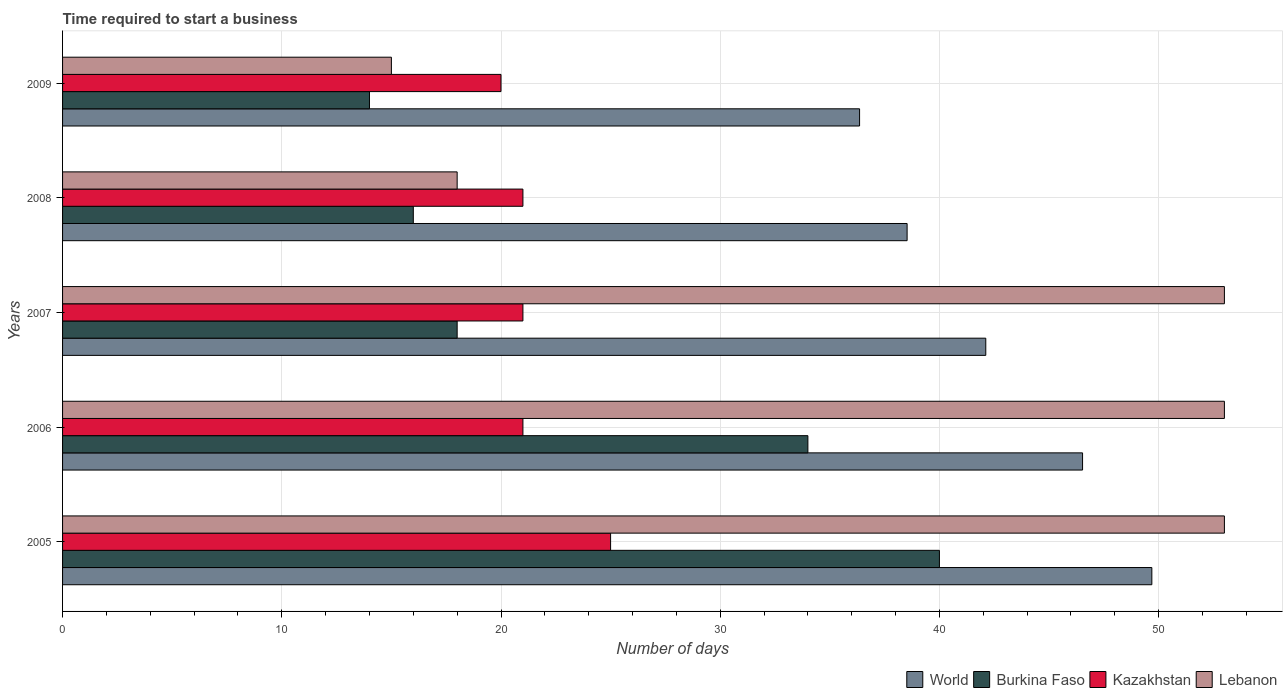How many different coloured bars are there?
Your answer should be very brief. 4. How many groups of bars are there?
Provide a short and direct response. 5. Are the number of bars per tick equal to the number of legend labels?
Offer a very short reply. Yes. How many bars are there on the 1st tick from the bottom?
Provide a short and direct response. 4. In how many cases, is the number of bars for a given year not equal to the number of legend labels?
Keep it short and to the point. 0. What is the number of days required to start a business in World in 2006?
Provide a succinct answer. 46.53. Across all years, what is the maximum number of days required to start a business in Burkina Faso?
Keep it short and to the point. 40. Across all years, what is the minimum number of days required to start a business in Burkina Faso?
Your answer should be compact. 14. What is the total number of days required to start a business in Kazakhstan in the graph?
Make the answer very short. 108. What is the difference between the number of days required to start a business in Burkina Faso in 2005 and that in 2009?
Provide a short and direct response. 26. What is the difference between the number of days required to start a business in Kazakhstan in 2006 and the number of days required to start a business in Burkina Faso in 2008?
Give a very brief answer. 5. What is the average number of days required to start a business in Lebanon per year?
Give a very brief answer. 38.4. In the year 2009, what is the difference between the number of days required to start a business in World and number of days required to start a business in Kazakhstan?
Make the answer very short. 16.36. What is the ratio of the number of days required to start a business in World in 2008 to that in 2009?
Your answer should be very brief. 1.06. Is the difference between the number of days required to start a business in World in 2006 and 2008 greater than the difference between the number of days required to start a business in Kazakhstan in 2006 and 2008?
Your answer should be compact. Yes. What is the difference between the highest and the second highest number of days required to start a business in Burkina Faso?
Provide a short and direct response. 6. What is the difference between the highest and the lowest number of days required to start a business in Lebanon?
Make the answer very short. 38. Is the sum of the number of days required to start a business in Burkina Faso in 2008 and 2009 greater than the maximum number of days required to start a business in World across all years?
Your answer should be compact. No. Is it the case that in every year, the sum of the number of days required to start a business in Burkina Faso and number of days required to start a business in Kazakhstan is greater than the sum of number of days required to start a business in World and number of days required to start a business in Lebanon?
Provide a short and direct response. No. Is it the case that in every year, the sum of the number of days required to start a business in Burkina Faso and number of days required to start a business in Kazakhstan is greater than the number of days required to start a business in World?
Make the answer very short. No. How many bars are there?
Keep it short and to the point. 20. How many years are there in the graph?
Offer a very short reply. 5. What is the difference between two consecutive major ticks on the X-axis?
Offer a terse response. 10. Are the values on the major ticks of X-axis written in scientific E-notation?
Your answer should be very brief. No. Does the graph contain grids?
Offer a very short reply. Yes. Where does the legend appear in the graph?
Your answer should be very brief. Bottom right. What is the title of the graph?
Give a very brief answer. Time required to start a business. Does "Algeria" appear as one of the legend labels in the graph?
Provide a short and direct response. No. What is the label or title of the X-axis?
Your response must be concise. Number of days. What is the label or title of the Y-axis?
Your response must be concise. Years. What is the Number of days in World in 2005?
Ensure brevity in your answer.  49.69. What is the Number of days of Lebanon in 2005?
Offer a very short reply. 53. What is the Number of days in World in 2006?
Give a very brief answer. 46.53. What is the Number of days in Lebanon in 2006?
Offer a terse response. 53. What is the Number of days of World in 2007?
Make the answer very short. 42.11. What is the Number of days in Lebanon in 2007?
Make the answer very short. 53. What is the Number of days of World in 2008?
Ensure brevity in your answer.  38.53. What is the Number of days of Burkina Faso in 2008?
Provide a short and direct response. 16. What is the Number of days of Lebanon in 2008?
Give a very brief answer. 18. What is the Number of days of World in 2009?
Your response must be concise. 36.36. What is the Number of days in Burkina Faso in 2009?
Offer a terse response. 14. What is the Number of days in Kazakhstan in 2009?
Offer a terse response. 20. What is the Number of days of Lebanon in 2009?
Your response must be concise. 15. Across all years, what is the maximum Number of days of World?
Ensure brevity in your answer.  49.69. Across all years, what is the maximum Number of days of Lebanon?
Your response must be concise. 53. Across all years, what is the minimum Number of days in World?
Provide a short and direct response. 36.36. Across all years, what is the minimum Number of days of Burkina Faso?
Your response must be concise. 14. Across all years, what is the minimum Number of days of Lebanon?
Your response must be concise. 15. What is the total Number of days of World in the graph?
Provide a short and direct response. 213.22. What is the total Number of days in Burkina Faso in the graph?
Offer a terse response. 122. What is the total Number of days in Kazakhstan in the graph?
Ensure brevity in your answer.  108. What is the total Number of days of Lebanon in the graph?
Provide a short and direct response. 192. What is the difference between the Number of days in World in 2005 and that in 2006?
Offer a terse response. 3.16. What is the difference between the Number of days of Burkina Faso in 2005 and that in 2006?
Your answer should be compact. 6. What is the difference between the Number of days of Lebanon in 2005 and that in 2006?
Your answer should be very brief. 0. What is the difference between the Number of days of World in 2005 and that in 2007?
Make the answer very short. 7.58. What is the difference between the Number of days of World in 2005 and that in 2008?
Offer a very short reply. 11.16. What is the difference between the Number of days in Burkina Faso in 2005 and that in 2008?
Make the answer very short. 24. What is the difference between the Number of days in Lebanon in 2005 and that in 2008?
Your response must be concise. 35. What is the difference between the Number of days in World in 2005 and that in 2009?
Offer a very short reply. 13.33. What is the difference between the Number of days in Burkina Faso in 2005 and that in 2009?
Make the answer very short. 26. What is the difference between the Number of days of Kazakhstan in 2005 and that in 2009?
Provide a short and direct response. 5. What is the difference between the Number of days in Lebanon in 2005 and that in 2009?
Your answer should be compact. 38. What is the difference between the Number of days of World in 2006 and that in 2007?
Provide a succinct answer. 4.42. What is the difference between the Number of days in Kazakhstan in 2006 and that in 2007?
Your answer should be compact. 0. What is the difference between the Number of days of World in 2006 and that in 2008?
Provide a succinct answer. 8. What is the difference between the Number of days in Burkina Faso in 2006 and that in 2008?
Offer a terse response. 18. What is the difference between the Number of days in World in 2006 and that in 2009?
Your response must be concise. 10.17. What is the difference between the Number of days of Burkina Faso in 2006 and that in 2009?
Provide a succinct answer. 20. What is the difference between the Number of days of Kazakhstan in 2006 and that in 2009?
Your answer should be very brief. 1. What is the difference between the Number of days in World in 2007 and that in 2008?
Provide a succinct answer. 3.59. What is the difference between the Number of days in Kazakhstan in 2007 and that in 2008?
Your response must be concise. 0. What is the difference between the Number of days in Lebanon in 2007 and that in 2008?
Give a very brief answer. 35. What is the difference between the Number of days in World in 2007 and that in 2009?
Make the answer very short. 5.76. What is the difference between the Number of days of Burkina Faso in 2007 and that in 2009?
Offer a terse response. 4. What is the difference between the Number of days in Kazakhstan in 2007 and that in 2009?
Make the answer very short. 1. What is the difference between the Number of days in World in 2008 and that in 2009?
Make the answer very short. 2.17. What is the difference between the Number of days of Burkina Faso in 2008 and that in 2009?
Your response must be concise. 2. What is the difference between the Number of days of Lebanon in 2008 and that in 2009?
Ensure brevity in your answer.  3. What is the difference between the Number of days in World in 2005 and the Number of days in Burkina Faso in 2006?
Your answer should be compact. 15.69. What is the difference between the Number of days in World in 2005 and the Number of days in Kazakhstan in 2006?
Offer a very short reply. 28.69. What is the difference between the Number of days of World in 2005 and the Number of days of Lebanon in 2006?
Offer a very short reply. -3.31. What is the difference between the Number of days of Burkina Faso in 2005 and the Number of days of Lebanon in 2006?
Offer a very short reply. -13. What is the difference between the Number of days in World in 2005 and the Number of days in Burkina Faso in 2007?
Your response must be concise. 31.69. What is the difference between the Number of days of World in 2005 and the Number of days of Kazakhstan in 2007?
Keep it short and to the point. 28.69. What is the difference between the Number of days in World in 2005 and the Number of days in Lebanon in 2007?
Provide a short and direct response. -3.31. What is the difference between the Number of days of Kazakhstan in 2005 and the Number of days of Lebanon in 2007?
Ensure brevity in your answer.  -28. What is the difference between the Number of days in World in 2005 and the Number of days in Burkina Faso in 2008?
Your answer should be compact. 33.69. What is the difference between the Number of days of World in 2005 and the Number of days of Kazakhstan in 2008?
Keep it short and to the point. 28.69. What is the difference between the Number of days in World in 2005 and the Number of days in Lebanon in 2008?
Give a very brief answer. 31.69. What is the difference between the Number of days of Kazakhstan in 2005 and the Number of days of Lebanon in 2008?
Make the answer very short. 7. What is the difference between the Number of days in World in 2005 and the Number of days in Burkina Faso in 2009?
Offer a very short reply. 35.69. What is the difference between the Number of days of World in 2005 and the Number of days of Kazakhstan in 2009?
Offer a terse response. 29.69. What is the difference between the Number of days in World in 2005 and the Number of days in Lebanon in 2009?
Provide a short and direct response. 34.69. What is the difference between the Number of days of Burkina Faso in 2005 and the Number of days of Lebanon in 2009?
Provide a short and direct response. 25. What is the difference between the Number of days in Kazakhstan in 2005 and the Number of days in Lebanon in 2009?
Your response must be concise. 10. What is the difference between the Number of days in World in 2006 and the Number of days in Burkina Faso in 2007?
Provide a succinct answer. 28.53. What is the difference between the Number of days of World in 2006 and the Number of days of Kazakhstan in 2007?
Your response must be concise. 25.53. What is the difference between the Number of days of World in 2006 and the Number of days of Lebanon in 2007?
Ensure brevity in your answer.  -6.47. What is the difference between the Number of days in Burkina Faso in 2006 and the Number of days in Lebanon in 2007?
Keep it short and to the point. -19. What is the difference between the Number of days of Kazakhstan in 2006 and the Number of days of Lebanon in 2007?
Give a very brief answer. -32. What is the difference between the Number of days of World in 2006 and the Number of days of Burkina Faso in 2008?
Make the answer very short. 30.53. What is the difference between the Number of days in World in 2006 and the Number of days in Kazakhstan in 2008?
Your answer should be compact. 25.53. What is the difference between the Number of days in World in 2006 and the Number of days in Lebanon in 2008?
Offer a terse response. 28.53. What is the difference between the Number of days in Burkina Faso in 2006 and the Number of days in Kazakhstan in 2008?
Keep it short and to the point. 13. What is the difference between the Number of days of Kazakhstan in 2006 and the Number of days of Lebanon in 2008?
Make the answer very short. 3. What is the difference between the Number of days of World in 2006 and the Number of days of Burkina Faso in 2009?
Keep it short and to the point. 32.53. What is the difference between the Number of days of World in 2006 and the Number of days of Kazakhstan in 2009?
Your answer should be very brief. 26.53. What is the difference between the Number of days in World in 2006 and the Number of days in Lebanon in 2009?
Ensure brevity in your answer.  31.53. What is the difference between the Number of days of Burkina Faso in 2006 and the Number of days of Lebanon in 2009?
Keep it short and to the point. 19. What is the difference between the Number of days in World in 2007 and the Number of days in Burkina Faso in 2008?
Ensure brevity in your answer.  26.11. What is the difference between the Number of days of World in 2007 and the Number of days of Kazakhstan in 2008?
Provide a succinct answer. 21.11. What is the difference between the Number of days in World in 2007 and the Number of days in Lebanon in 2008?
Provide a short and direct response. 24.11. What is the difference between the Number of days of Burkina Faso in 2007 and the Number of days of Kazakhstan in 2008?
Offer a terse response. -3. What is the difference between the Number of days in Burkina Faso in 2007 and the Number of days in Lebanon in 2008?
Offer a terse response. 0. What is the difference between the Number of days of Kazakhstan in 2007 and the Number of days of Lebanon in 2008?
Give a very brief answer. 3. What is the difference between the Number of days in World in 2007 and the Number of days in Burkina Faso in 2009?
Offer a very short reply. 28.11. What is the difference between the Number of days of World in 2007 and the Number of days of Kazakhstan in 2009?
Your answer should be very brief. 22.11. What is the difference between the Number of days in World in 2007 and the Number of days in Lebanon in 2009?
Provide a short and direct response. 27.11. What is the difference between the Number of days of Burkina Faso in 2007 and the Number of days of Lebanon in 2009?
Your answer should be very brief. 3. What is the difference between the Number of days of World in 2008 and the Number of days of Burkina Faso in 2009?
Your answer should be compact. 24.53. What is the difference between the Number of days of World in 2008 and the Number of days of Kazakhstan in 2009?
Offer a very short reply. 18.53. What is the difference between the Number of days of World in 2008 and the Number of days of Lebanon in 2009?
Keep it short and to the point. 23.53. What is the difference between the Number of days in Burkina Faso in 2008 and the Number of days in Lebanon in 2009?
Offer a very short reply. 1. What is the difference between the Number of days in Kazakhstan in 2008 and the Number of days in Lebanon in 2009?
Provide a short and direct response. 6. What is the average Number of days in World per year?
Make the answer very short. 42.64. What is the average Number of days in Burkina Faso per year?
Provide a succinct answer. 24.4. What is the average Number of days in Kazakhstan per year?
Your response must be concise. 21.6. What is the average Number of days of Lebanon per year?
Provide a short and direct response. 38.4. In the year 2005, what is the difference between the Number of days of World and Number of days of Burkina Faso?
Offer a very short reply. 9.69. In the year 2005, what is the difference between the Number of days in World and Number of days in Kazakhstan?
Provide a succinct answer. 24.69. In the year 2005, what is the difference between the Number of days in World and Number of days in Lebanon?
Give a very brief answer. -3.31. In the year 2005, what is the difference between the Number of days of Burkina Faso and Number of days of Kazakhstan?
Give a very brief answer. 15. In the year 2006, what is the difference between the Number of days in World and Number of days in Burkina Faso?
Give a very brief answer. 12.53. In the year 2006, what is the difference between the Number of days in World and Number of days in Kazakhstan?
Your answer should be very brief. 25.53. In the year 2006, what is the difference between the Number of days of World and Number of days of Lebanon?
Make the answer very short. -6.47. In the year 2006, what is the difference between the Number of days of Kazakhstan and Number of days of Lebanon?
Make the answer very short. -32. In the year 2007, what is the difference between the Number of days in World and Number of days in Burkina Faso?
Give a very brief answer. 24.11. In the year 2007, what is the difference between the Number of days in World and Number of days in Kazakhstan?
Provide a succinct answer. 21.11. In the year 2007, what is the difference between the Number of days of World and Number of days of Lebanon?
Your answer should be very brief. -10.89. In the year 2007, what is the difference between the Number of days of Burkina Faso and Number of days of Kazakhstan?
Give a very brief answer. -3. In the year 2007, what is the difference between the Number of days in Burkina Faso and Number of days in Lebanon?
Your answer should be compact. -35. In the year 2007, what is the difference between the Number of days of Kazakhstan and Number of days of Lebanon?
Give a very brief answer. -32. In the year 2008, what is the difference between the Number of days in World and Number of days in Burkina Faso?
Your response must be concise. 22.53. In the year 2008, what is the difference between the Number of days of World and Number of days of Kazakhstan?
Your response must be concise. 17.53. In the year 2008, what is the difference between the Number of days of World and Number of days of Lebanon?
Offer a terse response. 20.53. In the year 2008, what is the difference between the Number of days in Burkina Faso and Number of days in Kazakhstan?
Offer a very short reply. -5. In the year 2009, what is the difference between the Number of days in World and Number of days in Burkina Faso?
Offer a very short reply. 22.36. In the year 2009, what is the difference between the Number of days in World and Number of days in Kazakhstan?
Your answer should be very brief. 16.36. In the year 2009, what is the difference between the Number of days of World and Number of days of Lebanon?
Provide a short and direct response. 21.36. In the year 2009, what is the difference between the Number of days in Burkina Faso and Number of days in Kazakhstan?
Offer a very short reply. -6. In the year 2009, what is the difference between the Number of days in Kazakhstan and Number of days in Lebanon?
Provide a short and direct response. 5. What is the ratio of the Number of days in World in 2005 to that in 2006?
Provide a short and direct response. 1.07. What is the ratio of the Number of days in Burkina Faso in 2005 to that in 2006?
Make the answer very short. 1.18. What is the ratio of the Number of days in Kazakhstan in 2005 to that in 2006?
Ensure brevity in your answer.  1.19. What is the ratio of the Number of days in World in 2005 to that in 2007?
Offer a very short reply. 1.18. What is the ratio of the Number of days of Burkina Faso in 2005 to that in 2007?
Provide a succinct answer. 2.22. What is the ratio of the Number of days in Kazakhstan in 2005 to that in 2007?
Give a very brief answer. 1.19. What is the ratio of the Number of days in World in 2005 to that in 2008?
Your response must be concise. 1.29. What is the ratio of the Number of days of Burkina Faso in 2005 to that in 2008?
Your answer should be very brief. 2.5. What is the ratio of the Number of days in Kazakhstan in 2005 to that in 2008?
Offer a very short reply. 1.19. What is the ratio of the Number of days of Lebanon in 2005 to that in 2008?
Offer a terse response. 2.94. What is the ratio of the Number of days of World in 2005 to that in 2009?
Give a very brief answer. 1.37. What is the ratio of the Number of days of Burkina Faso in 2005 to that in 2009?
Keep it short and to the point. 2.86. What is the ratio of the Number of days in Lebanon in 2005 to that in 2009?
Offer a very short reply. 3.53. What is the ratio of the Number of days of World in 2006 to that in 2007?
Offer a terse response. 1.1. What is the ratio of the Number of days of Burkina Faso in 2006 to that in 2007?
Your response must be concise. 1.89. What is the ratio of the Number of days of Kazakhstan in 2006 to that in 2007?
Give a very brief answer. 1. What is the ratio of the Number of days in World in 2006 to that in 2008?
Give a very brief answer. 1.21. What is the ratio of the Number of days in Burkina Faso in 2006 to that in 2008?
Your answer should be compact. 2.12. What is the ratio of the Number of days of Kazakhstan in 2006 to that in 2008?
Your response must be concise. 1. What is the ratio of the Number of days of Lebanon in 2006 to that in 2008?
Your answer should be very brief. 2.94. What is the ratio of the Number of days of World in 2006 to that in 2009?
Keep it short and to the point. 1.28. What is the ratio of the Number of days of Burkina Faso in 2006 to that in 2009?
Provide a short and direct response. 2.43. What is the ratio of the Number of days in Kazakhstan in 2006 to that in 2009?
Provide a succinct answer. 1.05. What is the ratio of the Number of days of Lebanon in 2006 to that in 2009?
Your answer should be compact. 3.53. What is the ratio of the Number of days of World in 2007 to that in 2008?
Offer a terse response. 1.09. What is the ratio of the Number of days in Lebanon in 2007 to that in 2008?
Ensure brevity in your answer.  2.94. What is the ratio of the Number of days of World in 2007 to that in 2009?
Your answer should be compact. 1.16. What is the ratio of the Number of days of Burkina Faso in 2007 to that in 2009?
Provide a succinct answer. 1.29. What is the ratio of the Number of days of Lebanon in 2007 to that in 2009?
Provide a short and direct response. 3.53. What is the ratio of the Number of days of World in 2008 to that in 2009?
Offer a very short reply. 1.06. What is the ratio of the Number of days in Burkina Faso in 2008 to that in 2009?
Give a very brief answer. 1.14. What is the difference between the highest and the second highest Number of days of World?
Ensure brevity in your answer.  3.16. What is the difference between the highest and the second highest Number of days of Kazakhstan?
Give a very brief answer. 4. What is the difference between the highest and the second highest Number of days in Lebanon?
Your answer should be compact. 0. What is the difference between the highest and the lowest Number of days in World?
Offer a terse response. 13.33. What is the difference between the highest and the lowest Number of days of Burkina Faso?
Offer a terse response. 26. What is the difference between the highest and the lowest Number of days in Lebanon?
Offer a terse response. 38. 